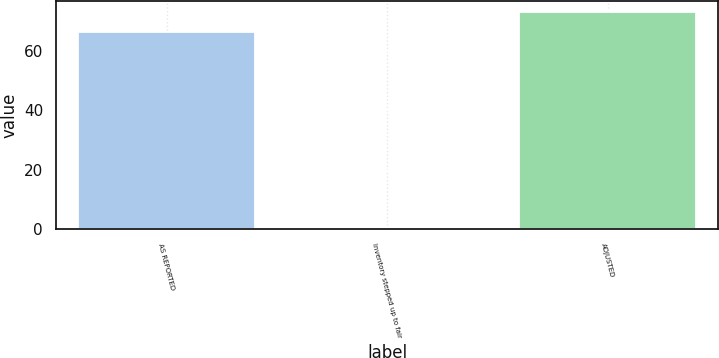<chart> <loc_0><loc_0><loc_500><loc_500><bar_chart><fcel>AS REPORTED<fcel>Inventory stepped up to fair<fcel>ADJUSTED<nl><fcel>66.4<fcel>0.1<fcel>73.04<nl></chart> 